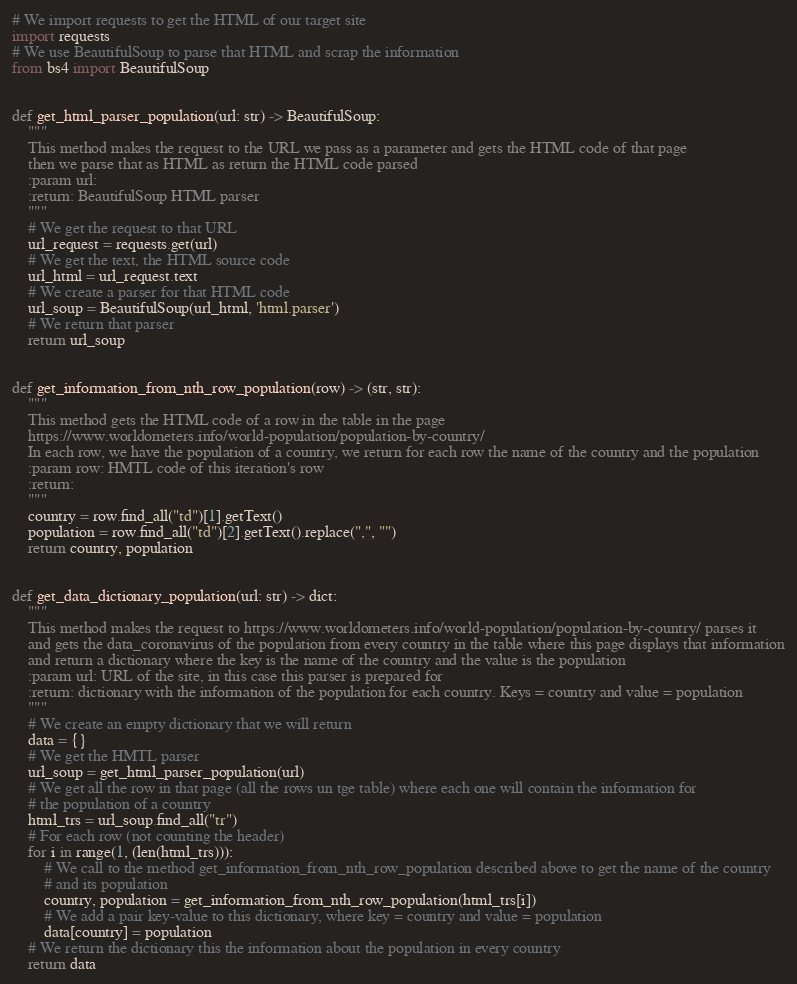<code> <loc_0><loc_0><loc_500><loc_500><_Python_># We import requests to get the HTML of our target site
import requests
# We use BeautifulSoup to parse that HTML and scrap the information
from bs4 import BeautifulSoup


def get_html_parser_population(url: str) -> BeautifulSoup:
    """
    This method makes the request to the URL we pass as a parameter and gets the HTML code of that page
    then we parse that as HTML as return the HTML code parsed
    :param url:
    :return: BeautifulSoup HTML parser
    """
    # We get the request to that URL
    url_request = requests.get(url)
    # We get the text, the HTML source code
    url_html = url_request.text
    # We create a parser for that HTML code
    url_soup = BeautifulSoup(url_html, 'html.parser')
    # We return that parser
    return url_soup


def get_information_from_nth_row_population(row) -> (str, str):
    """
    This method gets the HTML code of a row in the table in the page
    https://www.worldometers.info/world-population/population-by-country/
    In each row, we have the population of a country, we return for each row the name of the country and the population
    :param row: HMTL code of this iteration's row
    :return:
    """
    country = row.find_all("td")[1].getText()
    population = row.find_all("td")[2].getText().replace(",", "")
    return country, population


def get_data_dictionary_population(url: str) -> dict:
    """
    This method makes the request to https://www.worldometers.info/world-population/population-by-country/ parses it
    and gets the data_coronavirus of the population from every country in the table where this page displays that information
    and return a dictionary where the key is the name of the country and the value is the population
    :param url: URL of the site, in this case this parser is prepared for
    :return: dictionary with the information of the population for each country. Keys = country and value = population
    """
    # We create an empty dictionary that we will return
    data = {}
    # We get the HMTL parser
    url_soup = get_html_parser_population(url)
    # We get all the row in that page (all the rows un tge table) where each one will contain the information for
    # the population of a country
    html_trs = url_soup.find_all("tr")
    # For each row (not counting the header)
    for i in range(1, (len(html_trs))):
        # We call to the method get_information_from_nth_row_population described above to get the name of the country
        # and its population
        country, population = get_information_from_nth_row_population(html_trs[i])
        # We add a pair key-value to this dictionary, where key = country and value = population
        data[country] = population
    # We return the dictionary this the information about the population in every country
    return data
</code> 